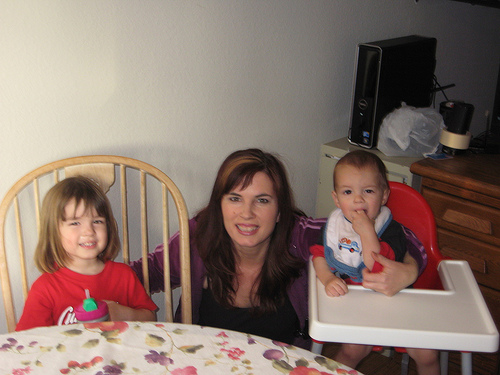<image>
Is there a boy baby to the left of the mom? Yes. From this viewpoint, the boy baby is positioned to the left side relative to the mom. Is the lady behind the boy? Yes. From this viewpoint, the lady is positioned behind the boy, with the boy partially or fully occluding the lady. 